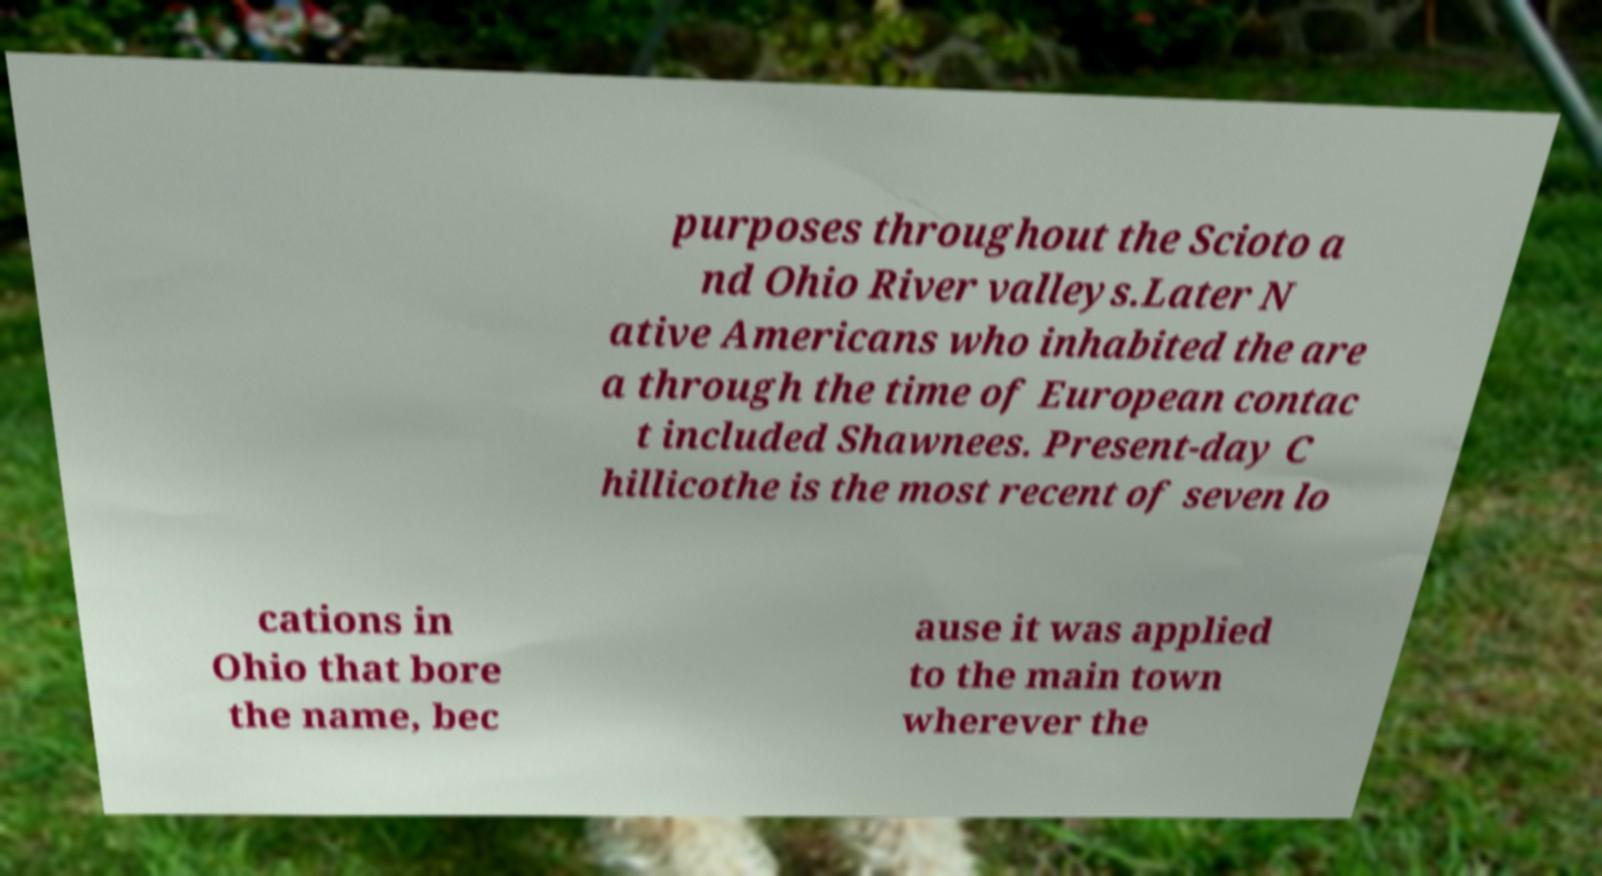Please read and relay the text visible in this image. What does it say? purposes throughout the Scioto a nd Ohio River valleys.Later N ative Americans who inhabited the are a through the time of European contac t included Shawnees. Present-day C hillicothe is the most recent of seven lo cations in Ohio that bore the name, bec ause it was applied to the main town wherever the 